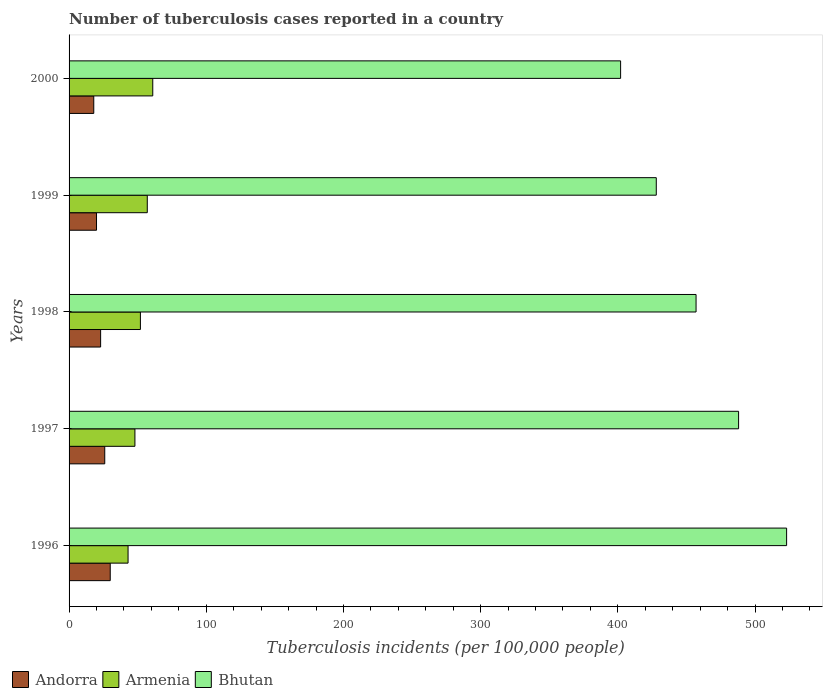Are the number of bars per tick equal to the number of legend labels?
Your answer should be very brief. Yes. Are the number of bars on each tick of the Y-axis equal?
Make the answer very short. Yes. How many bars are there on the 5th tick from the top?
Offer a very short reply. 3. How many bars are there on the 5th tick from the bottom?
Make the answer very short. 3. What is the number of tuberculosis cases reported in in Bhutan in 1998?
Provide a succinct answer. 457. Across all years, what is the maximum number of tuberculosis cases reported in in Armenia?
Ensure brevity in your answer.  61. Across all years, what is the minimum number of tuberculosis cases reported in in Bhutan?
Your response must be concise. 402. In which year was the number of tuberculosis cases reported in in Bhutan minimum?
Your response must be concise. 2000. What is the total number of tuberculosis cases reported in in Andorra in the graph?
Provide a succinct answer. 117. What is the difference between the number of tuberculosis cases reported in in Bhutan in 1996 and that in 1998?
Give a very brief answer. 66. What is the difference between the number of tuberculosis cases reported in in Andorra in 1997 and the number of tuberculosis cases reported in in Bhutan in 1999?
Offer a very short reply. -402. What is the average number of tuberculosis cases reported in in Andorra per year?
Give a very brief answer. 23.4. In the year 1997, what is the difference between the number of tuberculosis cases reported in in Andorra and number of tuberculosis cases reported in in Armenia?
Your answer should be very brief. -22. In how many years, is the number of tuberculosis cases reported in in Andorra greater than 380 ?
Give a very brief answer. 0. What is the ratio of the number of tuberculosis cases reported in in Armenia in 1999 to that in 2000?
Keep it short and to the point. 0.93. Is the number of tuberculosis cases reported in in Bhutan in 1996 less than that in 1997?
Ensure brevity in your answer.  No. Is the difference between the number of tuberculosis cases reported in in Andorra in 1998 and 1999 greater than the difference between the number of tuberculosis cases reported in in Armenia in 1998 and 1999?
Your response must be concise. Yes. What is the difference between the highest and the second highest number of tuberculosis cases reported in in Bhutan?
Make the answer very short. 35. What is the difference between the highest and the lowest number of tuberculosis cases reported in in Armenia?
Ensure brevity in your answer.  18. What does the 2nd bar from the top in 1997 represents?
Your response must be concise. Armenia. What does the 1st bar from the bottom in 2000 represents?
Your response must be concise. Andorra. How many bars are there?
Offer a terse response. 15. Are the values on the major ticks of X-axis written in scientific E-notation?
Provide a succinct answer. No. Does the graph contain any zero values?
Your answer should be compact. No. What is the title of the graph?
Ensure brevity in your answer.  Number of tuberculosis cases reported in a country. Does "Afghanistan" appear as one of the legend labels in the graph?
Make the answer very short. No. What is the label or title of the X-axis?
Keep it short and to the point. Tuberculosis incidents (per 100,0 people). What is the label or title of the Y-axis?
Offer a terse response. Years. What is the Tuberculosis incidents (per 100,000 people) in Bhutan in 1996?
Your response must be concise. 523. What is the Tuberculosis incidents (per 100,000 people) in Andorra in 1997?
Keep it short and to the point. 26. What is the Tuberculosis incidents (per 100,000 people) in Armenia in 1997?
Give a very brief answer. 48. What is the Tuberculosis incidents (per 100,000 people) in Bhutan in 1997?
Your answer should be very brief. 488. What is the Tuberculosis incidents (per 100,000 people) of Armenia in 1998?
Ensure brevity in your answer.  52. What is the Tuberculosis incidents (per 100,000 people) in Bhutan in 1998?
Offer a terse response. 457. What is the Tuberculosis incidents (per 100,000 people) in Armenia in 1999?
Provide a short and direct response. 57. What is the Tuberculosis incidents (per 100,000 people) in Bhutan in 1999?
Offer a very short reply. 428. What is the Tuberculosis incidents (per 100,000 people) in Andorra in 2000?
Offer a very short reply. 18. What is the Tuberculosis incidents (per 100,000 people) in Bhutan in 2000?
Your answer should be compact. 402. Across all years, what is the maximum Tuberculosis incidents (per 100,000 people) of Bhutan?
Your answer should be very brief. 523. Across all years, what is the minimum Tuberculosis incidents (per 100,000 people) of Armenia?
Offer a terse response. 43. Across all years, what is the minimum Tuberculosis incidents (per 100,000 people) in Bhutan?
Offer a terse response. 402. What is the total Tuberculosis incidents (per 100,000 people) of Andorra in the graph?
Offer a very short reply. 117. What is the total Tuberculosis incidents (per 100,000 people) in Armenia in the graph?
Keep it short and to the point. 261. What is the total Tuberculosis incidents (per 100,000 people) of Bhutan in the graph?
Your answer should be compact. 2298. What is the difference between the Tuberculosis incidents (per 100,000 people) in Andorra in 1996 and that in 1997?
Offer a very short reply. 4. What is the difference between the Tuberculosis incidents (per 100,000 people) of Armenia in 1996 and that in 1997?
Offer a very short reply. -5. What is the difference between the Tuberculosis incidents (per 100,000 people) of Bhutan in 1996 and that in 1997?
Your response must be concise. 35. What is the difference between the Tuberculosis incidents (per 100,000 people) in Bhutan in 1996 and that in 1998?
Make the answer very short. 66. What is the difference between the Tuberculosis incidents (per 100,000 people) of Andorra in 1996 and that in 1999?
Make the answer very short. 10. What is the difference between the Tuberculosis incidents (per 100,000 people) of Bhutan in 1996 and that in 2000?
Your response must be concise. 121. What is the difference between the Tuberculosis incidents (per 100,000 people) in Andorra in 1997 and that in 1999?
Make the answer very short. 6. What is the difference between the Tuberculosis incidents (per 100,000 people) of Armenia in 1997 and that in 1999?
Offer a terse response. -9. What is the difference between the Tuberculosis incidents (per 100,000 people) of Bhutan in 1997 and that in 1999?
Ensure brevity in your answer.  60. What is the difference between the Tuberculosis incidents (per 100,000 people) in Andorra in 1997 and that in 2000?
Your answer should be compact. 8. What is the difference between the Tuberculosis incidents (per 100,000 people) in Armenia in 1997 and that in 2000?
Give a very brief answer. -13. What is the difference between the Tuberculosis incidents (per 100,000 people) in Bhutan in 1997 and that in 2000?
Give a very brief answer. 86. What is the difference between the Tuberculosis incidents (per 100,000 people) of Armenia in 1998 and that in 1999?
Provide a short and direct response. -5. What is the difference between the Tuberculosis incidents (per 100,000 people) of Bhutan in 1998 and that in 1999?
Your answer should be compact. 29. What is the difference between the Tuberculosis incidents (per 100,000 people) in Andorra in 1996 and the Tuberculosis incidents (per 100,000 people) in Armenia in 1997?
Keep it short and to the point. -18. What is the difference between the Tuberculosis incidents (per 100,000 people) in Andorra in 1996 and the Tuberculosis incidents (per 100,000 people) in Bhutan in 1997?
Your response must be concise. -458. What is the difference between the Tuberculosis incidents (per 100,000 people) of Armenia in 1996 and the Tuberculosis incidents (per 100,000 people) of Bhutan in 1997?
Your answer should be compact. -445. What is the difference between the Tuberculosis incidents (per 100,000 people) of Andorra in 1996 and the Tuberculosis incidents (per 100,000 people) of Bhutan in 1998?
Provide a short and direct response. -427. What is the difference between the Tuberculosis incidents (per 100,000 people) of Armenia in 1996 and the Tuberculosis incidents (per 100,000 people) of Bhutan in 1998?
Your answer should be compact. -414. What is the difference between the Tuberculosis incidents (per 100,000 people) in Andorra in 1996 and the Tuberculosis incidents (per 100,000 people) in Armenia in 1999?
Ensure brevity in your answer.  -27. What is the difference between the Tuberculosis incidents (per 100,000 people) of Andorra in 1996 and the Tuberculosis incidents (per 100,000 people) of Bhutan in 1999?
Ensure brevity in your answer.  -398. What is the difference between the Tuberculosis incidents (per 100,000 people) of Armenia in 1996 and the Tuberculosis incidents (per 100,000 people) of Bhutan in 1999?
Make the answer very short. -385. What is the difference between the Tuberculosis incidents (per 100,000 people) of Andorra in 1996 and the Tuberculosis incidents (per 100,000 people) of Armenia in 2000?
Give a very brief answer. -31. What is the difference between the Tuberculosis incidents (per 100,000 people) in Andorra in 1996 and the Tuberculosis incidents (per 100,000 people) in Bhutan in 2000?
Provide a short and direct response. -372. What is the difference between the Tuberculosis incidents (per 100,000 people) of Armenia in 1996 and the Tuberculosis incidents (per 100,000 people) of Bhutan in 2000?
Provide a succinct answer. -359. What is the difference between the Tuberculosis incidents (per 100,000 people) in Andorra in 1997 and the Tuberculosis incidents (per 100,000 people) in Armenia in 1998?
Your answer should be very brief. -26. What is the difference between the Tuberculosis incidents (per 100,000 people) of Andorra in 1997 and the Tuberculosis incidents (per 100,000 people) of Bhutan in 1998?
Your answer should be compact. -431. What is the difference between the Tuberculosis incidents (per 100,000 people) of Armenia in 1997 and the Tuberculosis incidents (per 100,000 people) of Bhutan in 1998?
Offer a very short reply. -409. What is the difference between the Tuberculosis incidents (per 100,000 people) of Andorra in 1997 and the Tuberculosis incidents (per 100,000 people) of Armenia in 1999?
Your response must be concise. -31. What is the difference between the Tuberculosis incidents (per 100,000 people) of Andorra in 1997 and the Tuberculosis incidents (per 100,000 people) of Bhutan in 1999?
Ensure brevity in your answer.  -402. What is the difference between the Tuberculosis incidents (per 100,000 people) of Armenia in 1997 and the Tuberculosis incidents (per 100,000 people) of Bhutan in 1999?
Provide a succinct answer. -380. What is the difference between the Tuberculosis incidents (per 100,000 people) of Andorra in 1997 and the Tuberculosis incidents (per 100,000 people) of Armenia in 2000?
Your response must be concise. -35. What is the difference between the Tuberculosis incidents (per 100,000 people) in Andorra in 1997 and the Tuberculosis incidents (per 100,000 people) in Bhutan in 2000?
Make the answer very short. -376. What is the difference between the Tuberculosis incidents (per 100,000 people) in Armenia in 1997 and the Tuberculosis incidents (per 100,000 people) in Bhutan in 2000?
Your answer should be very brief. -354. What is the difference between the Tuberculosis incidents (per 100,000 people) in Andorra in 1998 and the Tuberculosis incidents (per 100,000 people) in Armenia in 1999?
Your answer should be compact. -34. What is the difference between the Tuberculosis incidents (per 100,000 people) of Andorra in 1998 and the Tuberculosis incidents (per 100,000 people) of Bhutan in 1999?
Keep it short and to the point. -405. What is the difference between the Tuberculosis incidents (per 100,000 people) in Armenia in 1998 and the Tuberculosis incidents (per 100,000 people) in Bhutan in 1999?
Give a very brief answer. -376. What is the difference between the Tuberculosis incidents (per 100,000 people) of Andorra in 1998 and the Tuberculosis incidents (per 100,000 people) of Armenia in 2000?
Your response must be concise. -38. What is the difference between the Tuberculosis incidents (per 100,000 people) in Andorra in 1998 and the Tuberculosis incidents (per 100,000 people) in Bhutan in 2000?
Keep it short and to the point. -379. What is the difference between the Tuberculosis incidents (per 100,000 people) in Armenia in 1998 and the Tuberculosis incidents (per 100,000 people) in Bhutan in 2000?
Your response must be concise. -350. What is the difference between the Tuberculosis incidents (per 100,000 people) of Andorra in 1999 and the Tuberculosis incidents (per 100,000 people) of Armenia in 2000?
Keep it short and to the point. -41. What is the difference between the Tuberculosis incidents (per 100,000 people) of Andorra in 1999 and the Tuberculosis incidents (per 100,000 people) of Bhutan in 2000?
Your answer should be very brief. -382. What is the difference between the Tuberculosis incidents (per 100,000 people) of Armenia in 1999 and the Tuberculosis incidents (per 100,000 people) of Bhutan in 2000?
Your answer should be very brief. -345. What is the average Tuberculosis incidents (per 100,000 people) in Andorra per year?
Make the answer very short. 23.4. What is the average Tuberculosis incidents (per 100,000 people) in Armenia per year?
Keep it short and to the point. 52.2. What is the average Tuberculosis incidents (per 100,000 people) of Bhutan per year?
Your response must be concise. 459.6. In the year 1996, what is the difference between the Tuberculosis incidents (per 100,000 people) of Andorra and Tuberculosis incidents (per 100,000 people) of Bhutan?
Your answer should be very brief. -493. In the year 1996, what is the difference between the Tuberculosis incidents (per 100,000 people) in Armenia and Tuberculosis incidents (per 100,000 people) in Bhutan?
Ensure brevity in your answer.  -480. In the year 1997, what is the difference between the Tuberculosis incidents (per 100,000 people) of Andorra and Tuberculosis incidents (per 100,000 people) of Armenia?
Provide a short and direct response. -22. In the year 1997, what is the difference between the Tuberculosis incidents (per 100,000 people) in Andorra and Tuberculosis incidents (per 100,000 people) in Bhutan?
Your response must be concise. -462. In the year 1997, what is the difference between the Tuberculosis incidents (per 100,000 people) of Armenia and Tuberculosis incidents (per 100,000 people) of Bhutan?
Offer a very short reply. -440. In the year 1998, what is the difference between the Tuberculosis incidents (per 100,000 people) in Andorra and Tuberculosis incidents (per 100,000 people) in Armenia?
Offer a very short reply. -29. In the year 1998, what is the difference between the Tuberculosis incidents (per 100,000 people) of Andorra and Tuberculosis incidents (per 100,000 people) of Bhutan?
Your answer should be very brief. -434. In the year 1998, what is the difference between the Tuberculosis incidents (per 100,000 people) in Armenia and Tuberculosis incidents (per 100,000 people) in Bhutan?
Provide a succinct answer. -405. In the year 1999, what is the difference between the Tuberculosis incidents (per 100,000 people) of Andorra and Tuberculosis incidents (per 100,000 people) of Armenia?
Provide a short and direct response. -37. In the year 1999, what is the difference between the Tuberculosis incidents (per 100,000 people) of Andorra and Tuberculosis incidents (per 100,000 people) of Bhutan?
Keep it short and to the point. -408. In the year 1999, what is the difference between the Tuberculosis incidents (per 100,000 people) in Armenia and Tuberculosis incidents (per 100,000 people) in Bhutan?
Make the answer very short. -371. In the year 2000, what is the difference between the Tuberculosis incidents (per 100,000 people) in Andorra and Tuberculosis incidents (per 100,000 people) in Armenia?
Provide a succinct answer. -43. In the year 2000, what is the difference between the Tuberculosis incidents (per 100,000 people) in Andorra and Tuberculosis incidents (per 100,000 people) in Bhutan?
Make the answer very short. -384. In the year 2000, what is the difference between the Tuberculosis incidents (per 100,000 people) in Armenia and Tuberculosis incidents (per 100,000 people) in Bhutan?
Ensure brevity in your answer.  -341. What is the ratio of the Tuberculosis incidents (per 100,000 people) of Andorra in 1996 to that in 1997?
Provide a succinct answer. 1.15. What is the ratio of the Tuberculosis incidents (per 100,000 people) in Armenia in 1996 to that in 1997?
Keep it short and to the point. 0.9. What is the ratio of the Tuberculosis incidents (per 100,000 people) of Bhutan in 1996 to that in 1997?
Make the answer very short. 1.07. What is the ratio of the Tuberculosis incidents (per 100,000 people) in Andorra in 1996 to that in 1998?
Give a very brief answer. 1.3. What is the ratio of the Tuberculosis incidents (per 100,000 people) of Armenia in 1996 to that in 1998?
Your answer should be very brief. 0.83. What is the ratio of the Tuberculosis incidents (per 100,000 people) in Bhutan in 1996 to that in 1998?
Provide a short and direct response. 1.14. What is the ratio of the Tuberculosis incidents (per 100,000 people) of Armenia in 1996 to that in 1999?
Provide a short and direct response. 0.75. What is the ratio of the Tuberculosis incidents (per 100,000 people) in Bhutan in 1996 to that in 1999?
Ensure brevity in your answer.  1.22. What is the ratio of the Tuberculosis incidents (per 100,000 people) in Andorra in 1996 to that in 2000?
Provide a succinct answer. 1.67. What is the ratio of the Tuberculosis incidents (per 100,000 people) in Armenia in 1996 to that in 2000?
Provide a succinct answer. 0.7. What is the ratio of the Tuberculosis incidents (per 100,000 people) of Bhutan in 1996 to that in 2000?
Provide a succinct answer. 1.3. What is the ratio of the Tuberculosis incidents (per 100,000 people) of Andorra in 1997 to that in 1998?
Give a very brief answer. 1.13. What is the ratio of the Tuberculosis incidents (per 100,000 people) in Armenia in 1997 to that in 1998?
Provide a succinct answer. 0.92. What is the ratio of the Tuberculosis incidents (per 100,000 people) in Bhutan in 1997 to that in 1998?
Provide a short and direct response. 1.07. What is the ratio of the Tuberculosis incidents (per 100,000 people) in Armenia in 1997 to that in 1999?
Offer a terse response. 0.84. What is the ratio of the Tuberculosis incidents (per 100,000 people) in Bhutan in 1997 to that in 1999?
Your answer should be very brief. 1.14. What is the ratio of the Tuberculosis incidents (per 100,000 people) of Andorra in 1997 to that in 2000?
Offer a very short reply. 1.44. What is the ratio of the Tuberculosis incidents (per 100,000 people) in Armenia in 1997 to that in 2000?
Your answer should be very brief. 0.79. What is the ratio of the Tuberculosis incidents (per 100,000 people) in Bhutan in 1997 to that in 2000?
Provide a short and direct response. 1.21. What is the ratio of the Tuberculosis incidents (per 100,000 people) in Andorra in 1998 to that in 1999?
Provide a short and direct response. 1.15. What is the ratio of the Tuberculosis incidents (per 100,000 people) in Armenia in 1998 to that in 1999?
Keep it short and to the point. 0.91. What is the ratio of the Tuberculosis incidents (per 100,000 people) in Bhutan in 1998 to that in 1999?
Offer a very short reply. 1.07. What is the ratio of the Tuberculosis incidents (per 100,000 people) in Andorra in 1998 to that in 2000?
Your answer should be compact. 1.28. What is the ratio of the Tuberculosis incidents (per 100,000 people) of Armenia in 1998 to that in 2000?
Make the answer very short. 0.85. What is the ratio of the Tuberculosis incidents (per 100,000 people) of Bhutan in 1998 to that in 2000?
Your answer should be very brief. 1.14. What is the ratio of the Tuberculosis incidents (per 100,000 people) of Andorra in 1999 to that in 2000?
Make the answer very short. 1.11. What is the ratio of the Tuberculosis incidents (per 100,000 people) of Armenia in 1999 to that in 2000?
Make the answer very short. 0.93. What is the ratio of the Tuberculosis incidents (per 100,000 people) of Bhutan in 1999 to that in 2000?
Your answer should be very brief. 1.06. What is the difference between the highest and the second highest Tuberculosis incidents (per 100,000 people) in Andorra?
Your answer should be compact. 4. What is the difference between the highest and the second highest Tuberculosis incidents (per 100,000 people) of Armenia?
Provide a short and direct response. 4. What is the difference between the highest and the lowest Tuberculosis incidents (per 100,000 people) of Armenia?
Provide a short and direct response. 18. What is the difference between the highest and the lowest Tuberculosis incidents (per 100,000 people) of Bhutan?
Give a very brief answer. 121. 